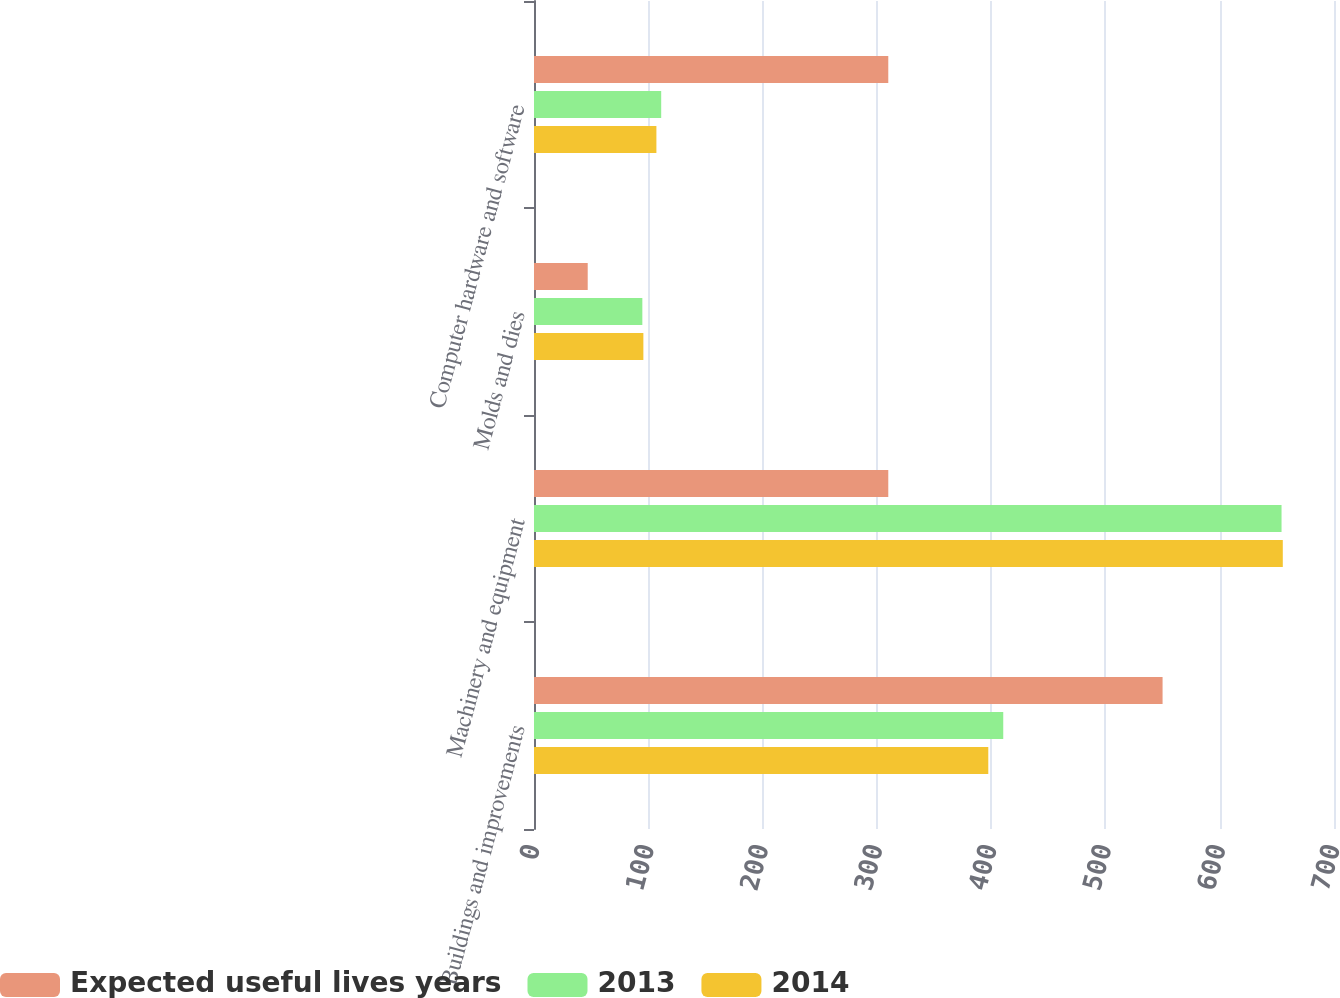Convert chart to OTSL. <chart><loc_0><loc_0><loc_500><loc_500><stacked_bar_chart><ecel><fcel>Buildings and improvements<fcel>Machinery and equipment<fcel>Molds and dies<fcel>Computer hardware and software<nl><fcel>Expected useful lives years<fcel>550<fcel>310<fcel>47<fcel>310<nl><fcel>2013<fcel>410.6<fcel>654.1<fcel>94.8<fcel>111.3<nl><fcel>2014<fcel>397.5<fcel>655.2<fcel>95.7<fcel>107.1<nl></chart> 